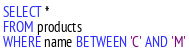<code> <loc_0><loc_0><loc_500><loc_500><_SQL_>SELECT *
FROM products
WHERE name BETWEEN 'C' AND 'M'
</code> 